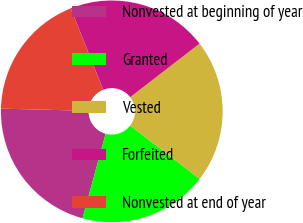Convert chart to OTSL. <chart><loc_0><loc_0><loc_500><loc_500><pie_chart><fcel>Nonvested at beginning of year<fcel>Granted<fcel>Vested<fcel>Forfeited<fcel>Nonvested at end of year<nl><fcel>21.14%<fcel>18.83%<fcel>20.88%<fcel>20.57%<fcel>18.58%<nl></chart> 